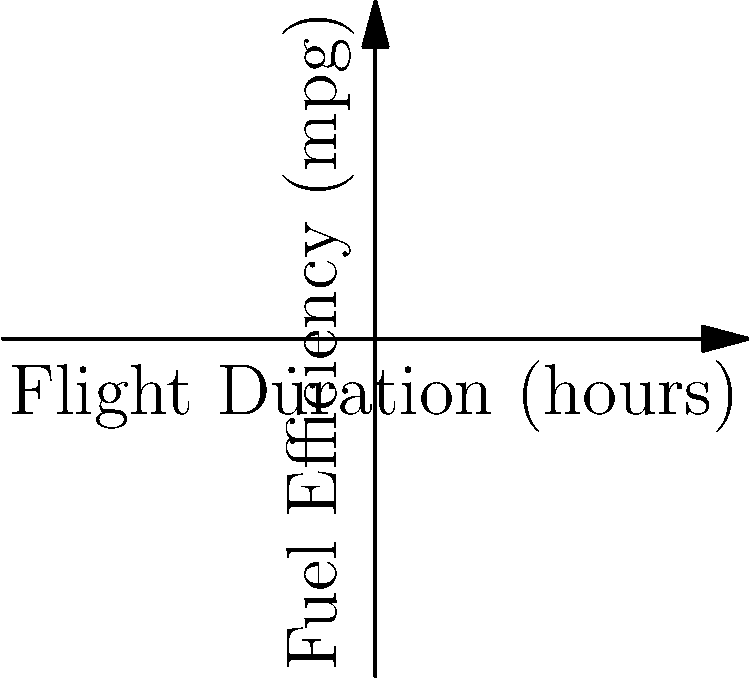As a flight attendant concerned with fuel efficiency, you're analyzing the fuel efficiency curves for two aircraft models. The graph shows the fuel efficiency (in miles per gallon) as a function of flight duration (in hours) for Model A (blue) and Model B (red). At what flight duration do both models have the same fuel efficiency, and what is this efficiency? To solve this problem, we need to follow these steps:

1) The point where both models have the same fuel efficiency is where the two curves intersect.

2) From the graph, we can visually estimate this point of intersection.

3) The x-coordinate of this point represents the flight duration where both models have the same efficiency.

4) The y-coordinate represents the fuel efficiency at this point.

5) Using the graph's scales and grid lines, we can estimate:
   - The flight duration (x-coordinate) is approximately 5.22 hours.
   - The fuel efficiency (y-coordinate) is approximately 4.98 mpg.

6) Therefore, both aircraft models have the same fuel efficiency of about 4.98 mpg when the flight duration is about 5.22 hours.

This graphical method provides a quick estimation. For more precise results, we would need to solve the equations of the two curves algebraically, which would involve more complex polynomial calculations.
Answer: 5.22 hours, 4.98 mpg 